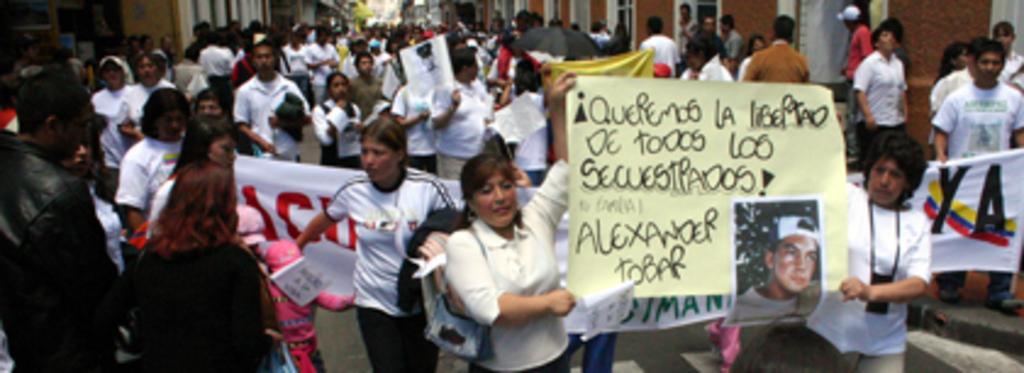Please provide a concise description of this image. In this image, we can see a crowd in between buildings. There are some persons holding banners with their hands. 